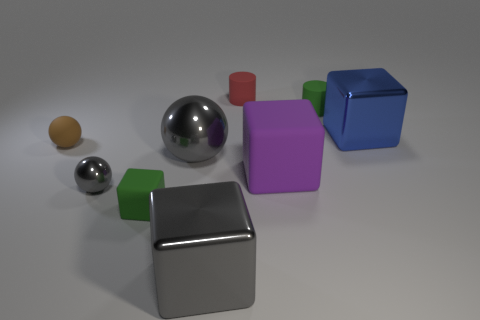Is the color of the large metal sphere the same as the tiny metal sphere?
Keep it short and to the point. Yes. Are there an equal number of shiny blocks to the left of the purple rubber block and tiny matte spheres?
Offer a terse response. Yes. The purple rubber cube is what size?
Make the answer very short. Large. What is the material of the cylinder that is the same color as the tiny block?
Your answer should be compact. Rubber. How many tiny matte things have the same color as the large rubber thing?
Offer a terse response. 0. Do the brown object and the purple thing have the same size?
Your answer should be compact. No. There is a metallic block that is in front of the shiny thing right of the gray cube; how big is it?
Give a very brief answer. Large. There is a tiny rubber cube; does it have the same color as the tiny cylinder to the right of the small red cylinder?
Offer a terse response. Yes. Is there a yellow shiny cylinder that has the same size as the red cylinder?
Your answer should be compact. No. What is the size of the green thing in front of the small green cylinder?
Offer a very short reply. Small. 